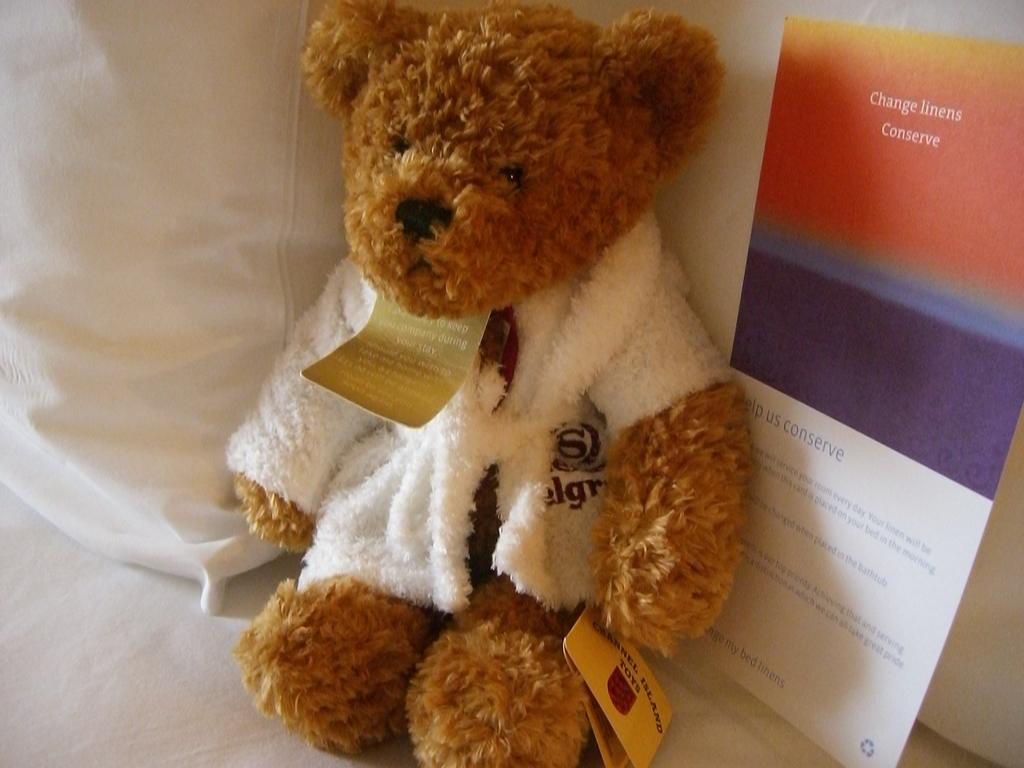Please provide a concise description of this image. This picture is mainly highlighted with a teddy bear which is brown in colour. Behind teddy bear we can see a board stating "change linens conserve". Here we can see a white pillow kind of thing. 